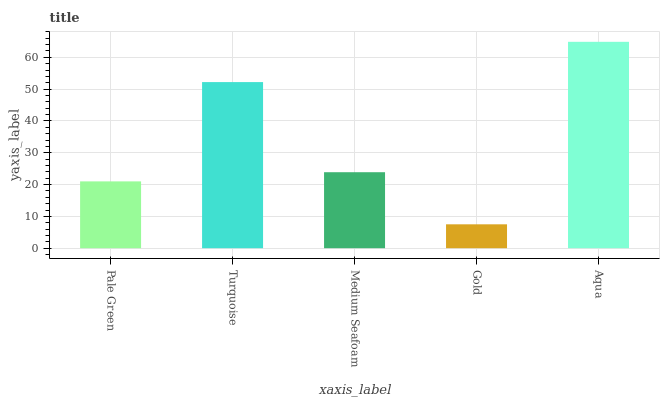Is Gold the minimum?
Answer yes or no. Yes. Is Aqua the maximum?
Answer yes or no. Yes. Is Turquoise the minimum?
Answer yes or no. No. Is Turquoise the maximum?
Answer yes or no. No. Is Turquoise greater than Pale Green?
Answer yes or no. Yes. Is Pale Green less than Turquoise?
Answer yes or no. Yes. Is Pale Green greater than Turquoise?
Answer yes or no. No. Is Turquoise less than Pale Green?
Answer yes or no. No. Is Medium Seafoam the high median?
Answer yes or no. Yes. Is Medium Seafoam the low median?
Answer yes or no. Yes. Is Turquoise the high median?
Answer yes or no. No. Is Turquoise the low median?
Answer yes or no. No. 